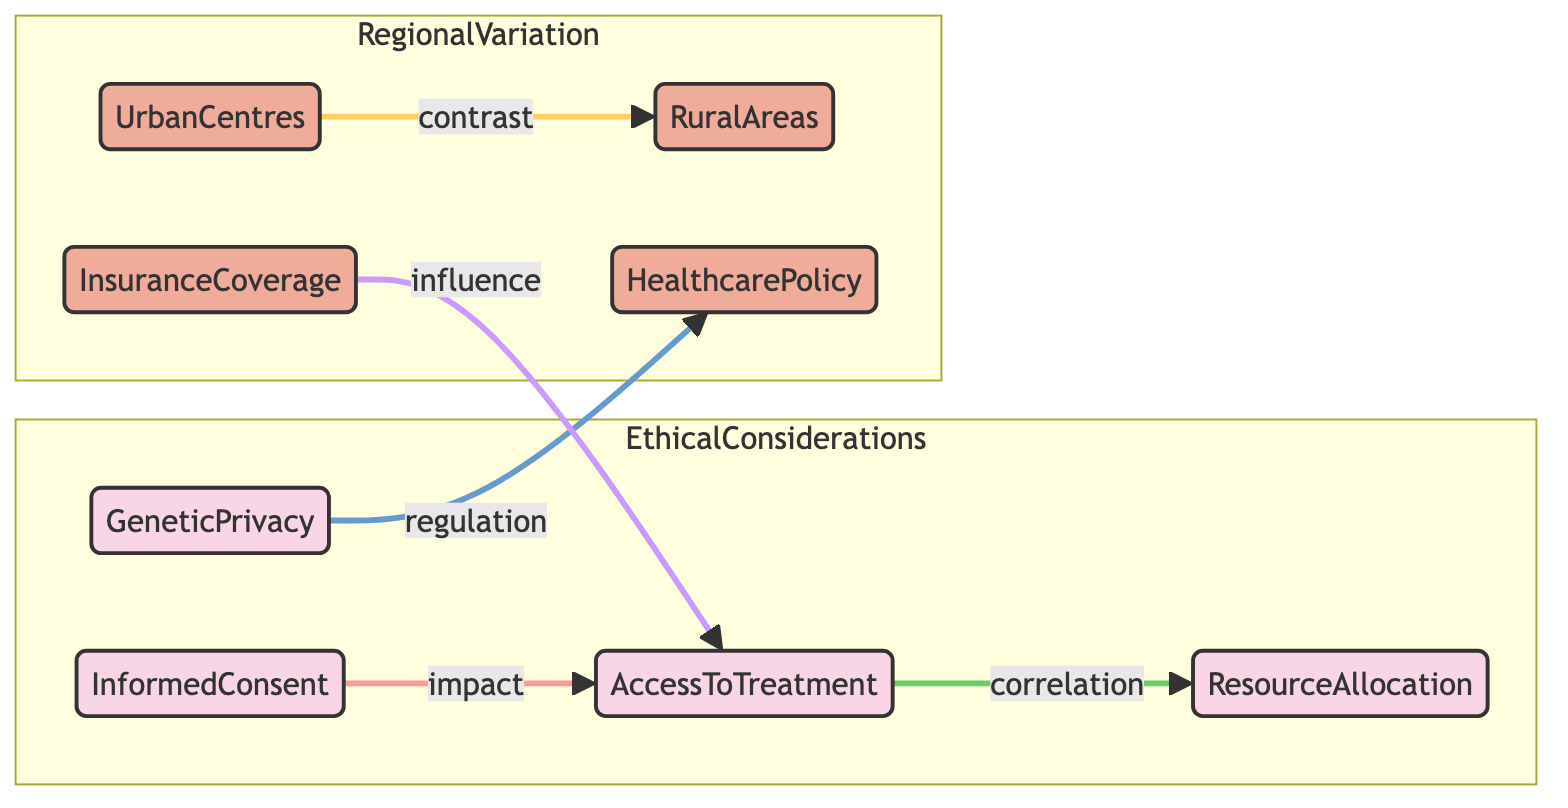What are the four ethical considerations depicted in the diagram? The diagram outlines four ethical considerations: Informed Consent, Access to Treatment, Resource Allocation, and Genetic Privacy. Each is enclosed in the "EthicalConsiderations" subgraph.
Answer: Informed Consent, Access to Treatment, Resource Allocation, Genetic Privacy Which nodes represent regional variation in the diagram? The regional variation nodes in the diagram are Urban Centres, Rural Areas, Healthcare Policy, and Insurance Coverage, located within the "RegionalVariation" subgraph.
Answer: Urban Centres, Rural Areas, Healthcare Policy, Insurance Coverage How many ethical considerations are connected to regional availability? In the diagram, Access to Treatment is impacted by Informed Consent and is also influenced by Insurance Coverage; these connections highlight the relationship between ethical considerations and regional availability. Thus, there are three connections when considering Access to Treatment's relations.
Answer: 3 What is the impact relationship between Informed Consent and Access to Treatment? The diagram shows that Informed Consent directly impacts Access to Treatment, indicating that individuals' understanding and permission affect their ability to receive treatment.
Answer: impact Which two nodes contrast in the diagram? The nodes Urban Centres and Rural Areas are specified as contrasting in the diagram, suggesting a disparity in treatment access based on geographic location.
Answer: Urban Centres, Rural Areas How does Genetic Privacy relate to Healthcare Policy in the diagram? The diagram illustrates that Genetic Privacy has a regulatory relationship with Healthcare Policy, indicating that privacy regulations influence healthcare policies surrounding reproductive treatments.
Answer: regulation What type of influence does Insurance Coverage have on Access to Treatment? The relationship depicted in the diagram shows that Insurance Coverage has an influence on Access to Treatment, suggesting that coverage policies directly affect patients' ability to obtain reproductive services.
Answer: influence Which ethical consideration is directly correlated with Resource Allocation? The diagram specifies a correlation between Access to Treatment and Resource Allocation, implying that the availability of treatment directly relates to how resources are allocated in reproductive medicine.
Answer: correlation 